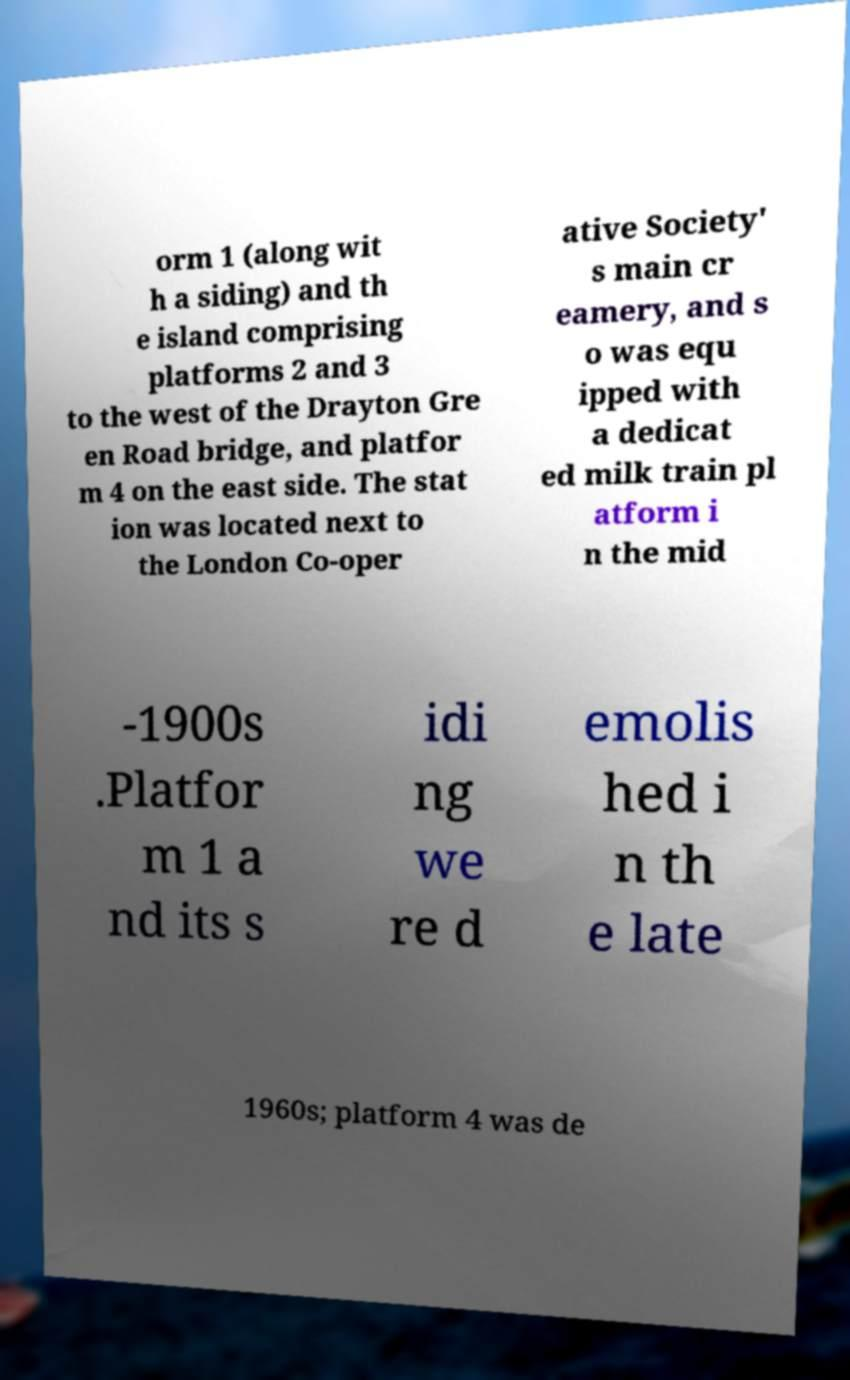Can you read and provide the text displayed in the image?This photo seems to have some interesting text. Can you extract and type it out for me? orm 1 (along wit h a siding) and th e island comprising platforms 2 and 3 to the west of the Drayton Gre en Road bridge, and platfor m 4 on the east side. The stat ion was located next to the London Co-oper ative Society' s main cr eamery, and s o was equ ipped with a dedicat ed milk train pl atform i n the mid -1900s .Platfor m 1 a nd its s idi ng we re d emolis hed i n th e late 1960s; platform 4 was de 